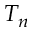Convert formula to latex. <formula><loc_0><loc_0><loc_500><loc_500>T _ { n }</formula> 